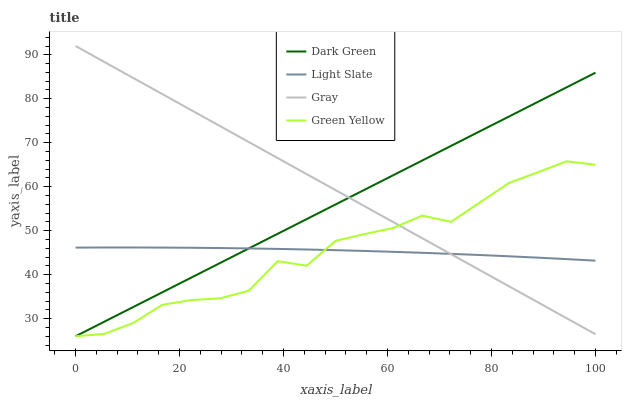Does Light Slate have the minimum area under the curve?
Answer yes or no. Yes. Does Gray have the maximum area under the curve?
Answer yes or no. Yes. Does Green Yellow have the minimum area under the curve?
Answer yes or no. No. Does Green Yellow have the maximum area under the curve?
Answer yes or no. No. Is Gray the smoothest?
Answer yes or no. Yes. Is Green Yellow the roughest?
Answer yes or no. Yes. Is Green Yellow the smoothest?
Answer yes or no. No. Is Gray the roughest?
Answer yes or no. No. Does Green Yellow have the lowest value?
Answer yes or no. Yes. Does Gray have the lowest value?
Answer yes or no. No. Does Gray have the highest value?
Answer yes or no. Yes. Does Green Yellow have the highest value?
Answer yes or no. No. Does Gray intersect Light Slate?
Answer yes or no. Yes. Is Gray less than Light Slate?
Answer yes or no. No. Is Gray greater than Light Slate?
Answer yes or no. No. 